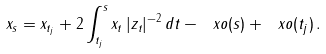Convert formula to latex. <formula><loc_0><loc_0><loc_500><loc_500>x _ { s } = x _ { t _ { j } } + 2 \int _ { t _ { j } } ^ { s } x _ { t } \, | z _ { t } | ^ { - 2 } \, d t - \ x o ( s ) + \ x o ( t _ { j } ) \, .</formula> 